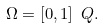Convert formula to latex. <formula><loc_0><loc_0><loc_500><loc_500>\Omega = [ 0 , 1 ] \ { Q } .</formula> 